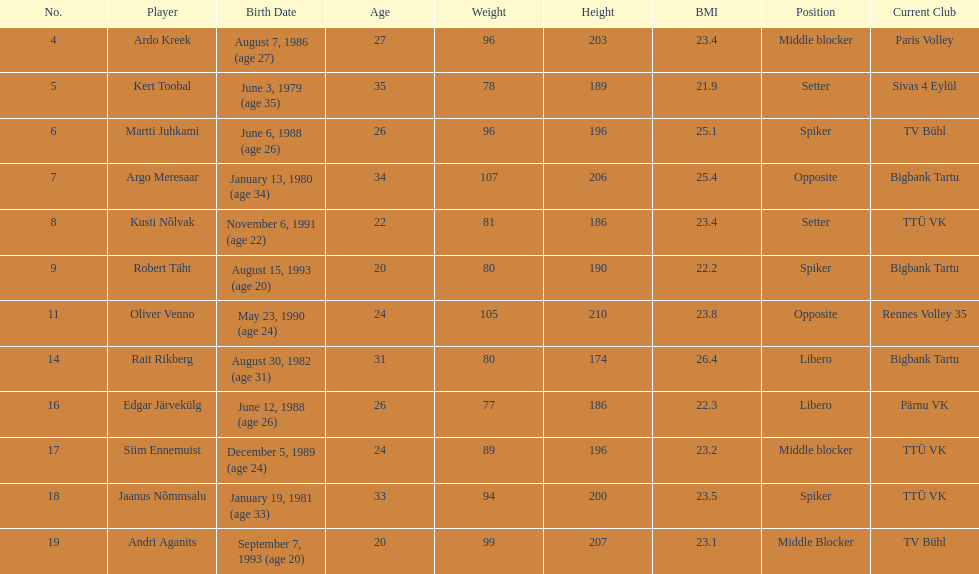Kert toobal is the oldest who is the next oldest player listed? Argo Meresaar. 